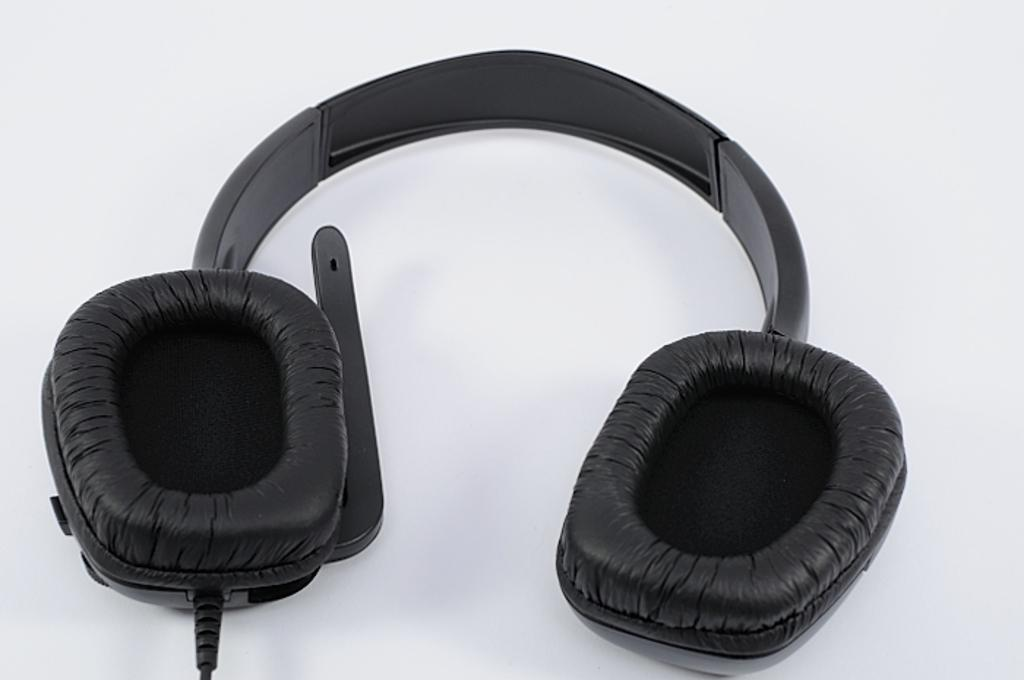What type of headphones are visible in the image? There are black color headphones in the image. What color is the object that the headphones are on? The headphones are on a white object. What is the price of the hose in the image? There is no hose present in the image, so it is not possible to determine its price. 